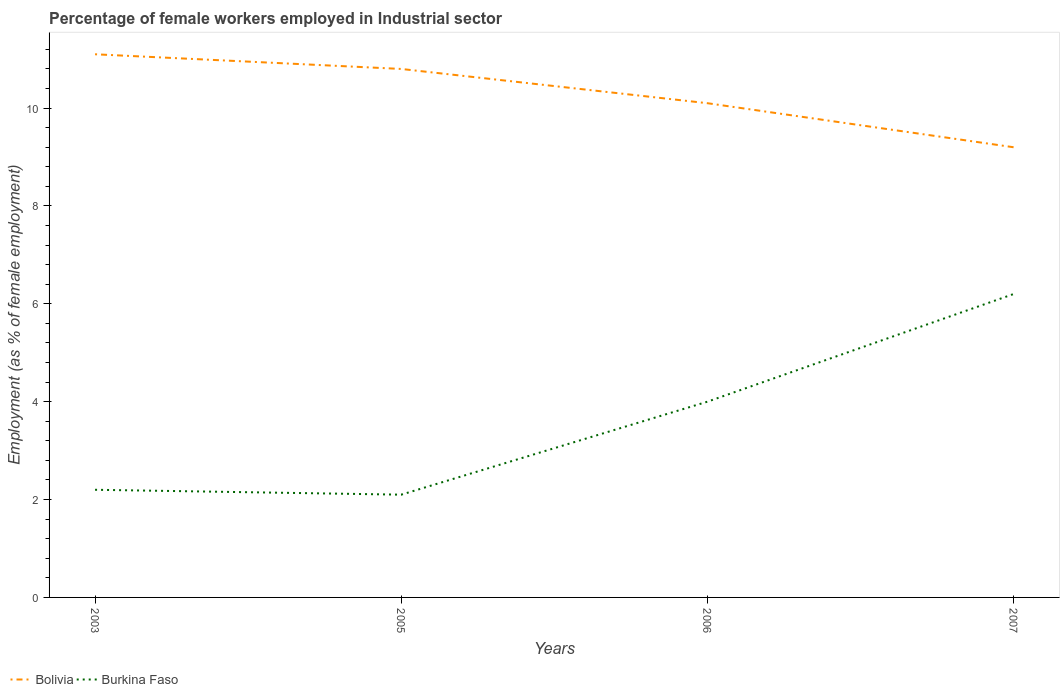Does the line corresponding to Bolivia intersect with the line corresponding to Burkina Faso?
Give a very brief answer. No. Across all years, what is the maximum percentage of females employed in Industrial sector in Bolivia?
Offer a very short reply. 9.2. What is the total percentage of females employed in Industrial sector in Burkina Faso in the graph?
Make the answer very short. 0.1. What is the difference between the highest and the second highest percentage of females employed in Industrial sector in Burkina Faso?
Ensure brevity in your answer.  4.1. How many lines are there?
Ensure brevity in your answer.  2. What is the difference between two consecutive major ticks on the Y-axis?
Offer a terse response. 2. Are the values on the major ticks of Y-axis written in scientific E-notation?
Make the answer very short. No. Does the graph contain any zero values?
Your answer should be very brief. No. What is the title of the graph?
Your response must be concise. Percentage of female workers employed in Industrial sector. What is the label or title of the Y-axis?
Your answer should be compact. Employment (as % of female employment). What is the Employment (as % of female employment) in Bolivia in 2003?
Ensure brevity in your answer.  11.1. What is the Employment (as % of female employment) of Burkina Faso in 2003?
Provide a succinct answer. 2.2. What is the Employment (as % of female employment) of Bolivia in 2005?
Your response must be concise. 10.8. What is the Employment (as % of female employment) in Burkina Faso in 2005?
Give a very brief answer. 2.1. What is the Employment (as % of female employment) of Bolivia in 2006?
Your response must be concise. 10.1. What is the Employment (as % of female employment) of Bolivia in 2007?
Keep it short and to the point. 9.2. What is the Employment (as % of female employment) of Burkina Faso in 2007?
Offer a very short reply. 6.2. Across all years, what is the maximum Employment (as % of female employment) in Bolivia?
Offer a terse response. 11.1. Across all years, what is the maximum Employment (as % of female employment) of Burkina Faso?
Your answer should be very brief. 6.2. Across all years, what is the minimum Employment (as % of female employment) of Bolivia?
Your answer should be very brief. 9.2. Across all years, what is the minimum Employment (as % of female employment) of Burkina Faso?
Provide a short and direct response. 2.1. What is the total Employment (as % of female employment) of Bolivia in the graph?
Keep it short and to the point. 41.2. What is the total Employment (as % of female employment) in Burkina Faso in the graph?
Provide a succinct answer. 14.5. What is the difference between the Employment (as % of female employment) of Burkina Faso in 2003 and that in 2005?
Make the answer very short. 0.1. What is the difference between the Employment (as % of female employment) in Bolivia in 2003 and that in 2006?
Offer a terse response. 1. What is the difference between the Employment (as % of female employment) of Burkina Faso in 2003 and that in 2007?
Ensure brevity in your answer.  -4. What is the difference between the Employment (as % of female employment) in Burkina Faso in 2006 and that in 2007?
Ensure brevity in your answer.  -2.2. What is the difference between the Employment (as % of female employment) in Bolivia in 2003 and the Employment (as % of female employment) in Burkina Faso in 2006?
Offer a very short reply. 7.1. What is the difference between the Employment (as % of female employment) in Bolivia in 2005 and the Employment (as % of female employment) in Burkina Faso in 2007?
Offer a terse response. 4.6. What is the difference between the Employment (as % of female employment) of Bolivia in 2006 and the Employment (as % of female employment) of Burkina Faso in 2007?
Provide a short and direct response. 3.9. What is the average Employment (as % of female employment) in Bolivia per year?
Keep it short and to the point. 10.3. What is the average Employment (as % of female employment) in Burkina Faso per year?
Your answer should be compact. 3.62. In the year 2005, what is the difference between the Employment (as % of female employment) of Bolivia and Employment (as % of female employment) of Burkina Faso?
Ensure brevity in your answer.  8.7. In the year 2006, what is the difference between the Employment (as % of female employment) in Bolivia and Employment (as % of female employment) in Burkina Faso?
Give a very brief answer. 6.1. In the year 2007, what is the difference between the Employment (as % of female employment) in Bolivia and Employment (as % of female employment) in Burkina Faso?
Provide a succinct answer. 3. What is the ratio of the Employment (as % of female employment) of Bolivia in 2003 to that in 2005?
Give a very brief answer. 1.03. What is the ratio of the Employment (as % of female employment) of Burkina Faso in 2003 to that in 2005?
Provide a succinct answer. 1.05. What is the ratio of the Employment (as % of female employment) in Bolivia in 2003 to that in 2006?
Your response must be concise. 1.1. What is the ratio of the Employment (as % of female employment) in Burkina Faso in 2003 to that in 2006?
Give a very brief answer. 0.55. What is the ratio of the Employment (as % of female employment) of Bolivia in 2003 to that in 2007?
Your response must be concise. 1.21. What is the ratio of the Employment (as % of female employment) in Burkina Faso in 2003 to that in 2007?
Offer a terse response. 0.35. What is the ratio of the Employment (as % of female employment) in Bolivia in 2005 to that in 2006?
Offer a very short reply. 1.07. What is the ratio of the Employment (as % of female employment) of Burkina Faso in 2005 to that in 2006?
Provide a short and direct response. 0.53. What is the ratio of the Employment (as % of female employment) of Bolivia in 2005 to that in 2007?
Your response must be concise. 1.17. What is the ratio of the Employment (as % of female employment) in Burkina Faso in 2005 to that in 2007?
Provide a short and direct response. 0.34. What is the ratio of the Employment (as % of female employment) of Bolivia in 2006 to that in 2007?
Give a very brief answer. 1.1. What is the ratio of the Employment (as % of female employment) of Burkina Faso in 2006 to that in 2007?
Offer a terse response. 0.65. What is the difference between the highest and the second highest Employment (as % of female employment) in Bolivia?
Your answer should be compact. 0.3. What is the difference between the highest and the second highest Employment (as % of female employment) of Burkina Faso?
Provide a succinct answer. 2.2. 